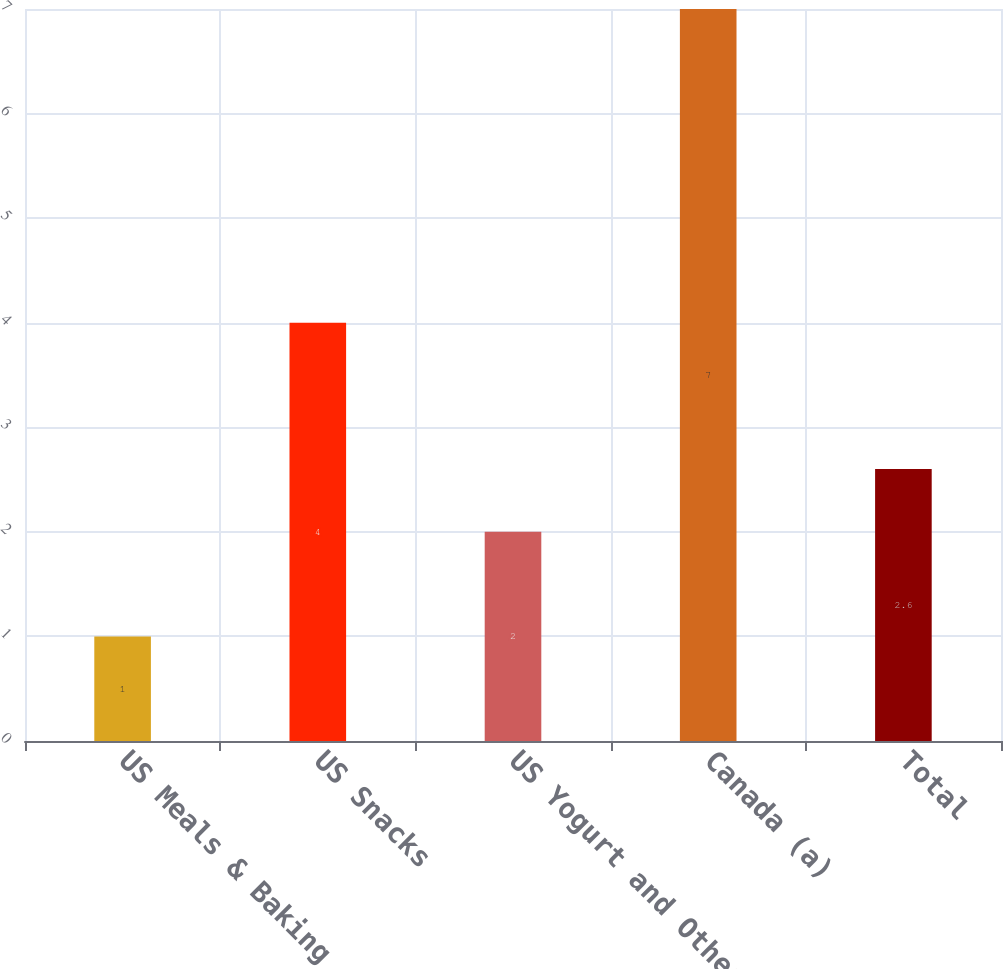<chart> <loc_0><loc_0><loc_500><loc_500><bar_chart><fcel>US Meals & Baking<fcel>US Snacks<fcel>US Yogurt and Other<fcel>Canada (a)<fcel>Total<nl><fcel>1<fcel>4<fcel>2<fcel>7<fcel>2.6<nl></chart> 